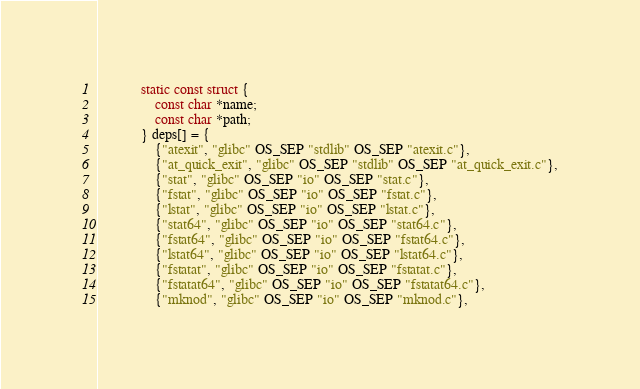Convert code to text. <code><loc_0><loc_0><loc_500><loc_500><_C++_>            static const struct {
                const char *name;
                const char *path;
            } deps[] = {
                {"atexit", "glibc" OS_SEP "stdlib" OS_SEP "atexit.c"},
                {"at_quick_exit", "glibc" OS_SEP "stdlib" OS_SEP "at_quick_exit.c"},
                {"stat", "glibc" OS_SEP "io" OS_SEP "stat.c"},
                {"fstat", "glibc" OS_SEP "io" OS_SEP "fstat.c"},
                {"lstat", "glibc" OS_SEP "io" OS_SEP "lstat.c"},
                {"stat64", "glibc" OS_SEP "io" OS_SEP "stat64.c"},
                {"fstat64", "glibc" OS_SEP "io" OS_SEP "fstat64.c"},
                {"lstat64", "glibc" OS_SEP "io" OS_SEP "lstat64.c"},
                {"fstatat", "glibc" OS_SEP "io" OS_SEP "fstatat.c"},
                {"fstatat64", "glibc" OS_SEP "io" OS_SEP "fstatat64.c"},
                {"mknod", "glibc" OS_SEP "io" OS_SEP "mknod.c"},</code> 